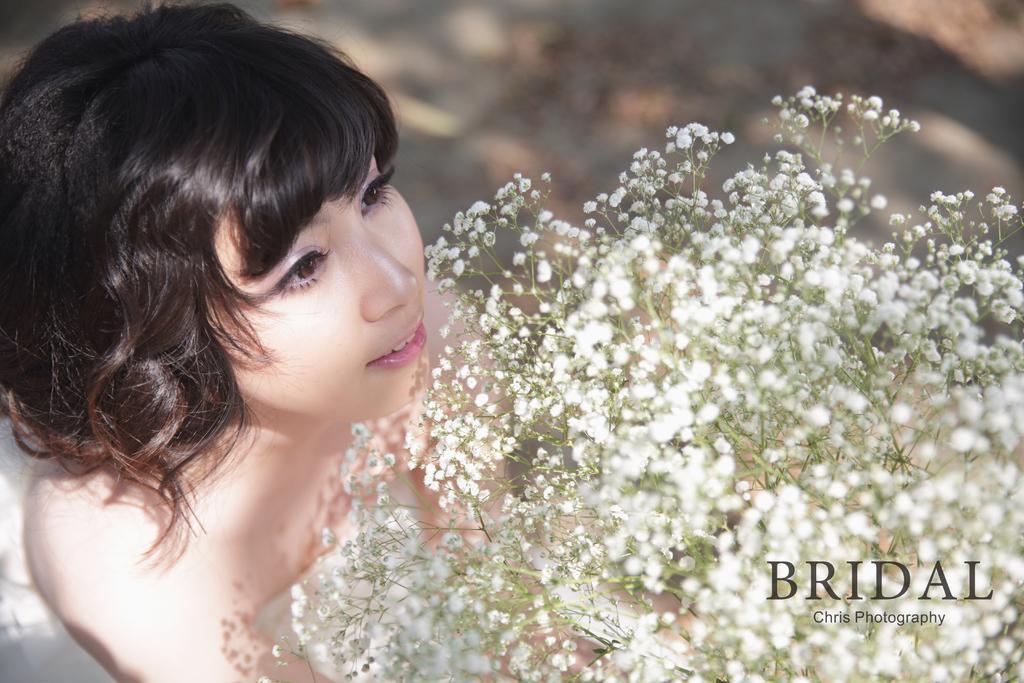Could you give a brief overview of what you see in this image? In this picture we can see a lady is holding a bouquet. At the bottom right corner some text is there. In the background the image is blur. 